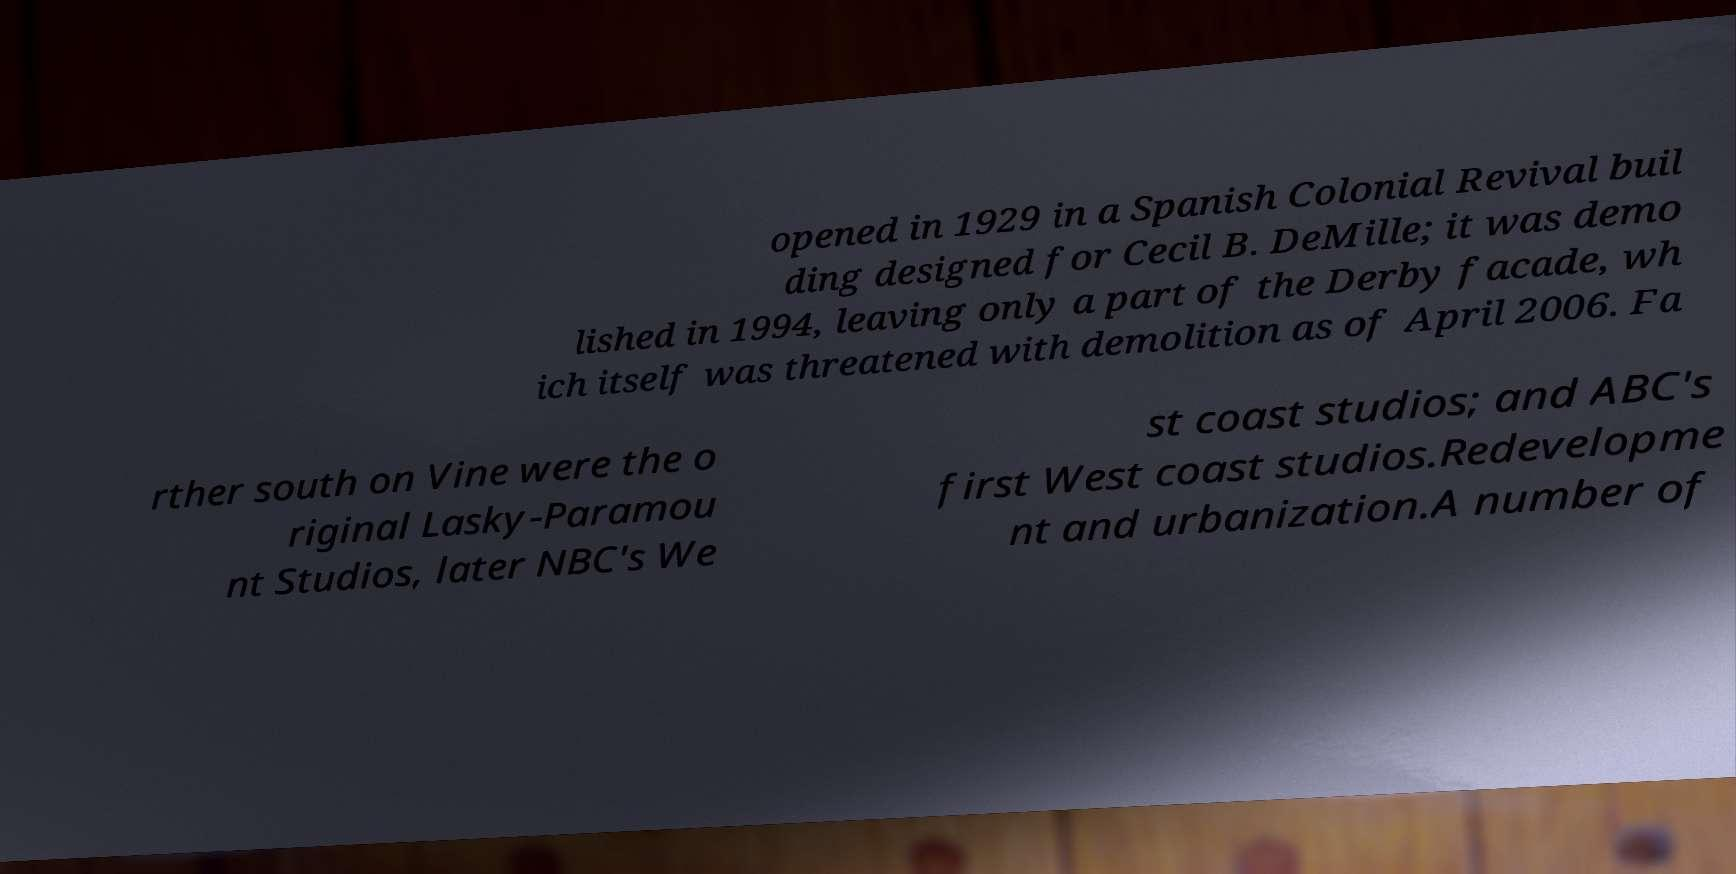Could you assist in decoding the text presented in this image and type it out clearly? opened in 1929 in a Spanish Colonial Revival buil ding designed for Cecil B. DeMille; it was demo lished in 1994, leaving only a part of the Derby facade, wh ich itself was threatened with demolition as of April 2006. Fa rther south on Vine were the o riginal Lasky-Paramou nt Studios, later NBC's We st coast studios; and ABC's first West coast studios.Redevelopme nt and urbanization.A number of 